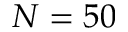Convert formula to latex. <formula><loc_0><loc_0><loc_500><loc_500>N = 5 0</formula> 